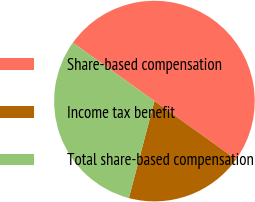Convert chart. <chart><loc_0><loc_0><loc_500><loc_500><pie_chart><fcel>Share-based compensation<fcel>Income tax benefit<fcel>Total share-based compensation<nl><fcel>50.0%<fcel>19.23%<fcel>30.77%<nl></chart> 